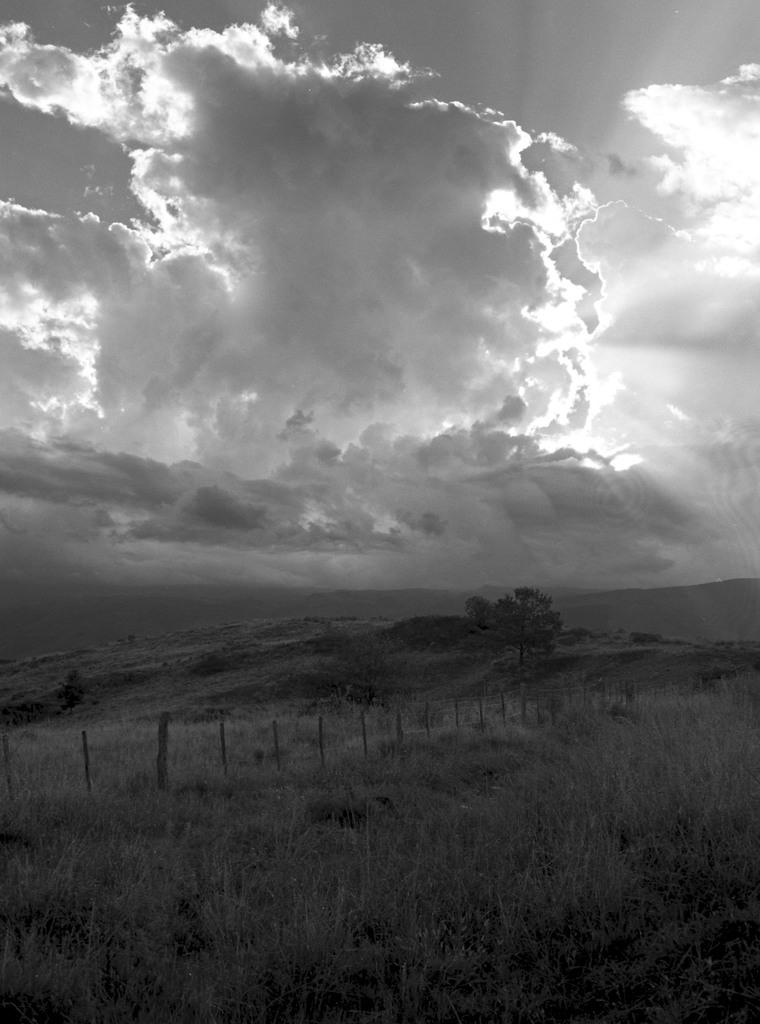What type of plant can be seen in the image? There is a tree in the image. What type of barrier is present in the image? There is fencing in the image. What is the condition of the ground in the image? Dry grass is visible in the image. What is the weather like in the image? The sky is cloudy in the image. What type of sun can be seen in the image? There is no sun visible in the image, as it is in black and white. What kind of trouble is the tree experiencing in the image? There is no indication of trouble for the tree in the image; it appears to be standing normally. 